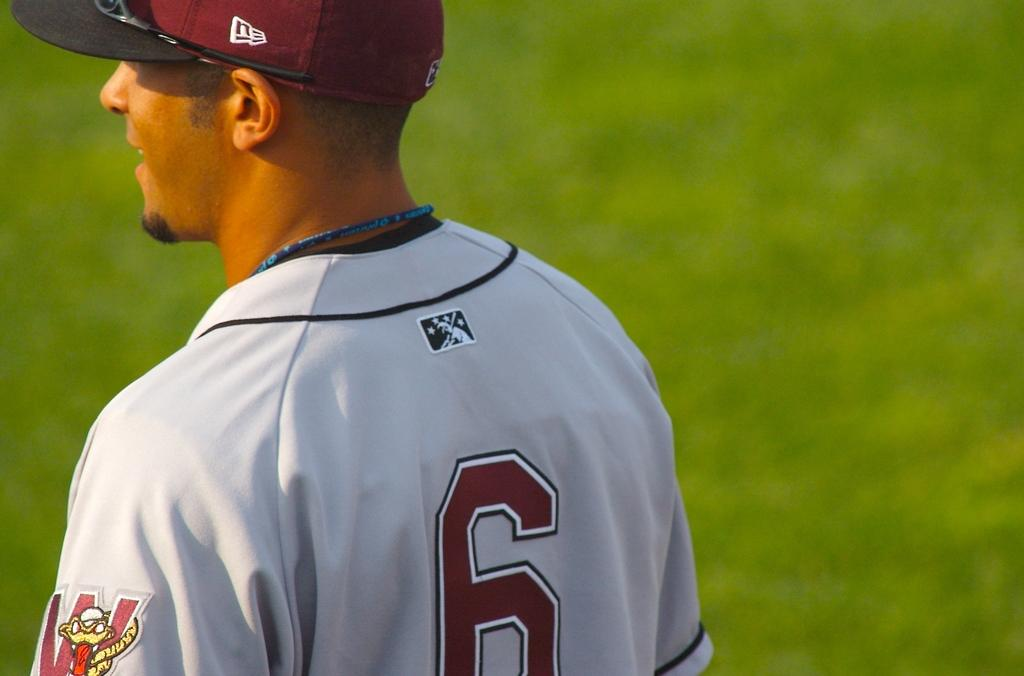<image>
Offer a succinct explanation of the picture presented. A baseball player wears a jersey with the number 6 on the back. 